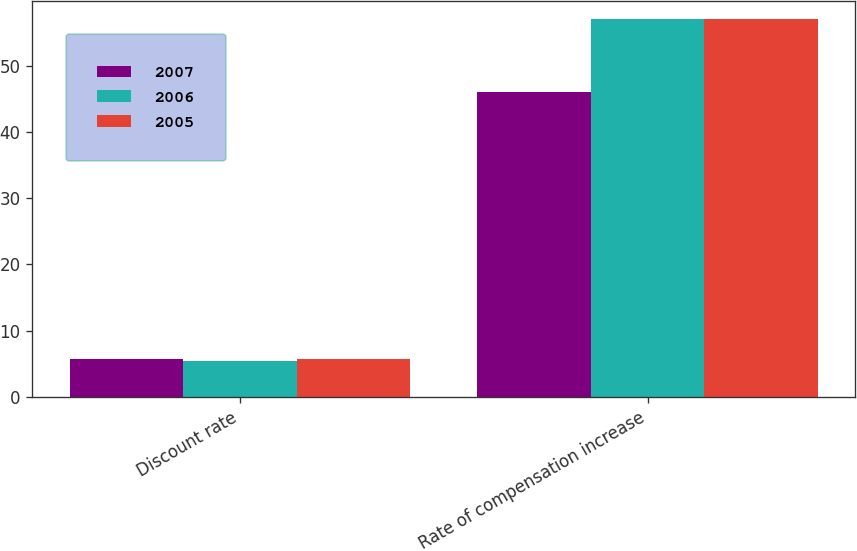Convert chart. <chart><loc_0><loc_0><loc_500><loc_500><stacked_bar_chart><ecel><fcel>Discount rate<fcel>Rate of compensation increase<nl><fcel>2007<fcel>5.75<fcel>46<nl><fcel>2006<fcel>5.5<fcel>57<nl><fcel>2005<fcel>5.75<fcel>57<nl></chart> 